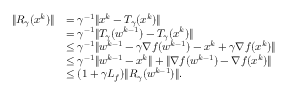<formula> <loc_0><loc_0><loc_500><loc_500>\begin{array} { r l } { \| R _ { \gamma } ( x ^ { k } ) \| } & { = \gamma ^ { - 1 } \| x ^ { k } - T _ { \gamma } ( x ^ { k } ) \| } \\ & { = \gamma ^ { - 1 } \| T _ { \gamma } ( w ^ { k - 1 } ) - T _ { \gamma } ( x ^ { k } ) \| } \\ & { \leq \gamma ^ { - 1 } \| w ^ { k - 1 } - \gamma \nabla f ( w ^ { k - 1 } ) - x ^ { k } + \gamma \nabla f ( x ^ { k } ) \| } \\ & { \leq \gamma ^ { - 1 } \| w ^ { k - 1 } - x ^ { k } \| + \| \nabla f ( w ^ { k - 1 } ) - \nabla f ( x ^ { k } ) \| } \\ & { \leq ( 1 + \gamma L _ { f } ) \| R _ { \gamma } ( w ^ { k - 1 } ) \| . } \end{array}</formula> 